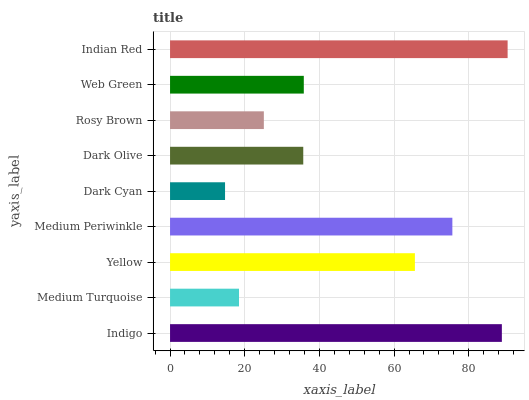Is Dark Cyan the minimum?
Answer yes or no. Yes. Is Indian Red the maximum?
Answer yes or no. Yes. Is Medium Turquoise the minimum?
Answer yes or no. No. Is Medium Turquoise the maximum?
Answer yes or no. No. Is Indigo greater than Medium Turquoise?
Answer yes or no. Yes. Is Medium Turquoise less than Indigo?
Answer yes or no. Yes. Is Medium Turquoise greater than Indigo?
Answer yes or no. No. Is Indigo less than Medium Turquoise?
Answer yes or no. No. Is Web Green the high median?
Answer yes or no. Yes. Is Web Green the low median?
Answer yes or no. Yes. Is Rosy Brown the high median?
Answer yes or no. No. Is Medium Turquoise the low median?
Answer yes or no. No. 